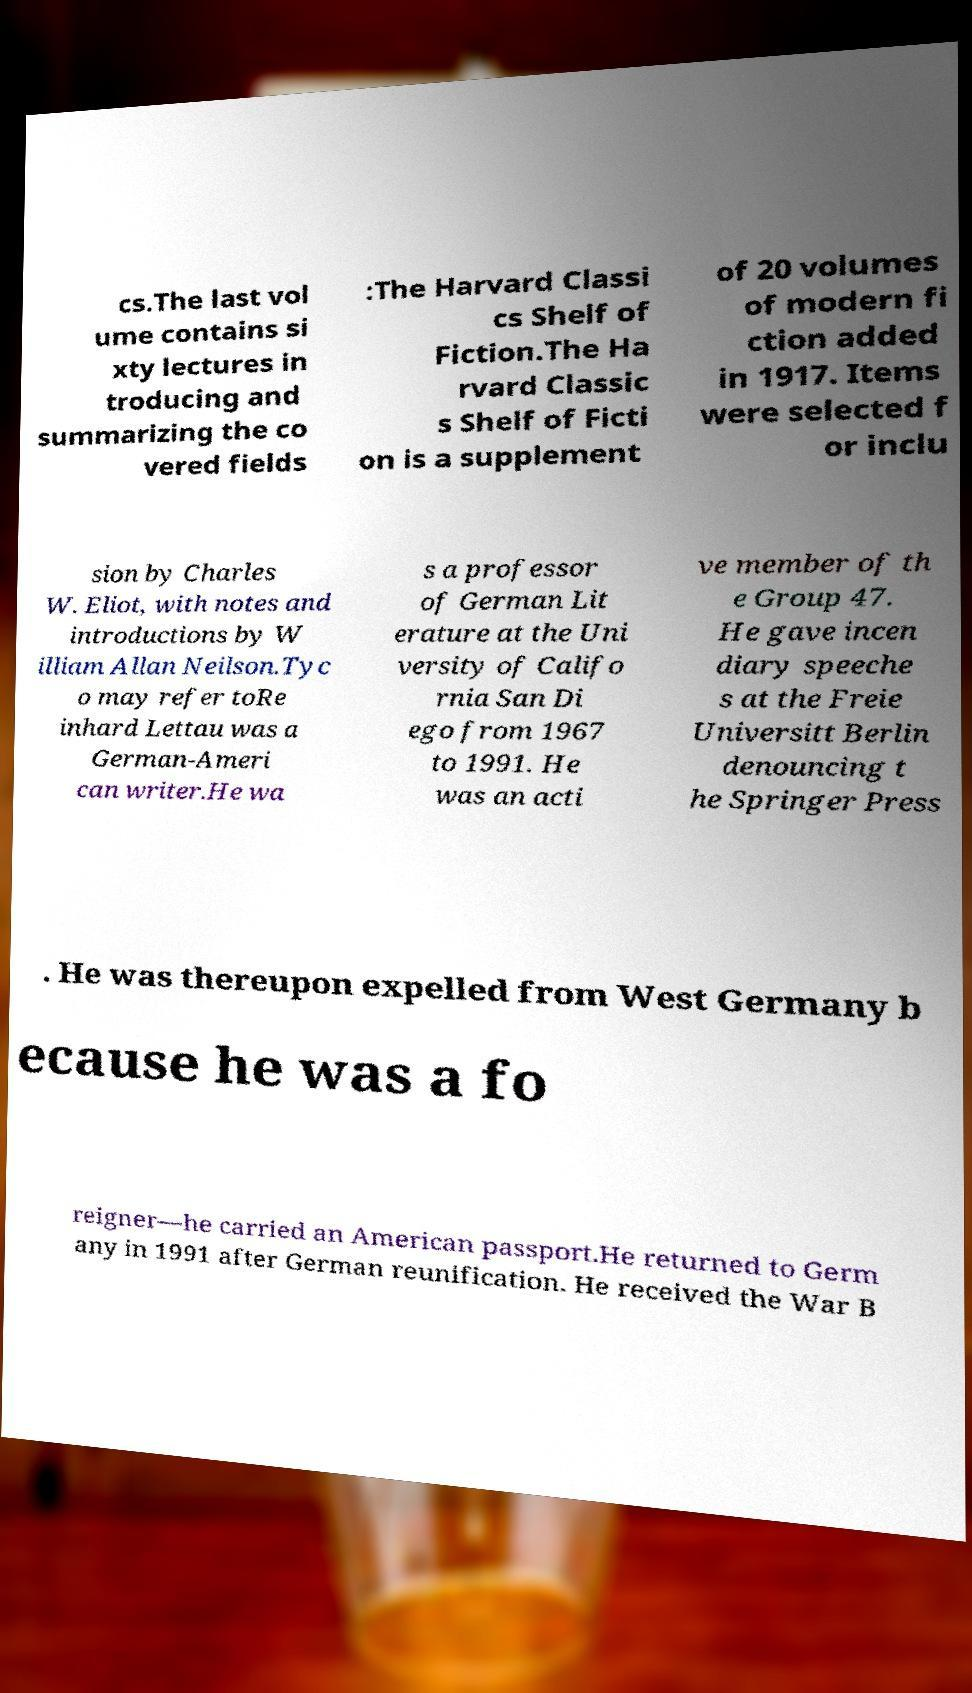What messages or text are displayed in this image? I need them in a readable, typed format. cs.The last vol ume contains si xty lectures in troducing and summarizing the co vered fields :The Harvard Classi cs Shelf of Fiction.The Ha rvard Classic s Shelf of Ficti on is a supplement of 20 volumes of modern fi ction added in 1917. Items were selected f or inclu sion by Charles W. Eliot, with notes and introductions by W illiam Allan Neilson.Tyc o may refer toRe inhard Lettau was a German-Ameri can writer.He wa s a professor of German Lit erature at the Uni versity of Califo rnia San Di ego from 1967 to 1991. He was an acti ve member of th e Group 47. He gave incen diary speeche s at the Freie Universitt Berlin denouncing t he Springer Press . He was thereupon expelled from West Germany b ecause he was a fo reigner—he carried an American passport.He returned to Germ any in 1991 after German reunification. He received the War B 